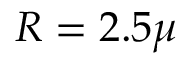<formula> <loc_0><loc_0><loc_500><loc_500>R = 2 . 5 \mu</formula> 